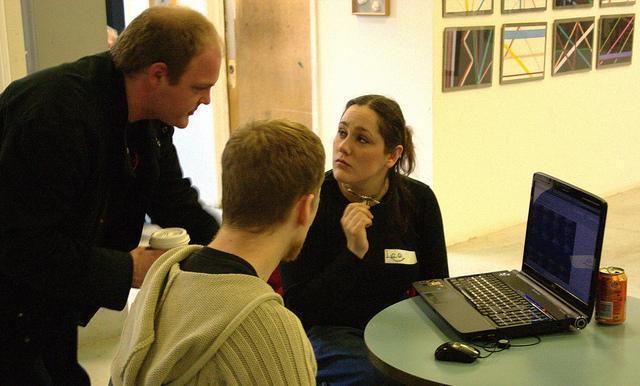What are the people assembled around?
From the following set of four choices, select the accurate answer to respond to the question.
Options: Laptop, dinner table, barbecue grill, movie screen. Laptop. 